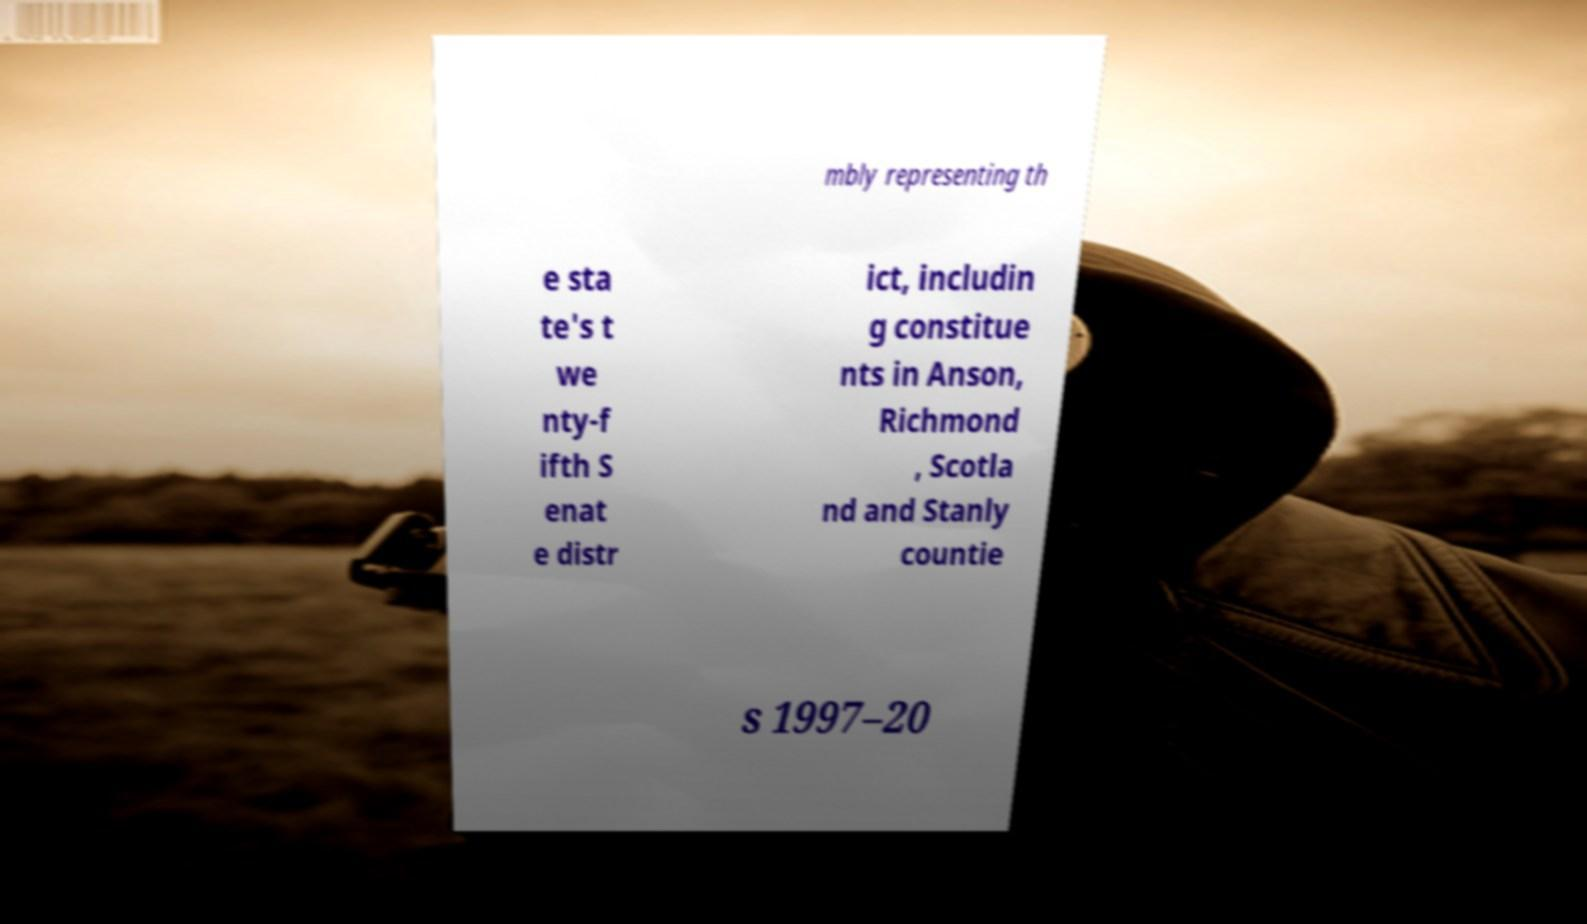Could you extract and type out the text from this image? mbly representing th e sta te's t we nty-f ifth S enat e distr ict, includin g constitue nts in Anson, Richmond , Scotla nd and Stanly countie s 1997–20 